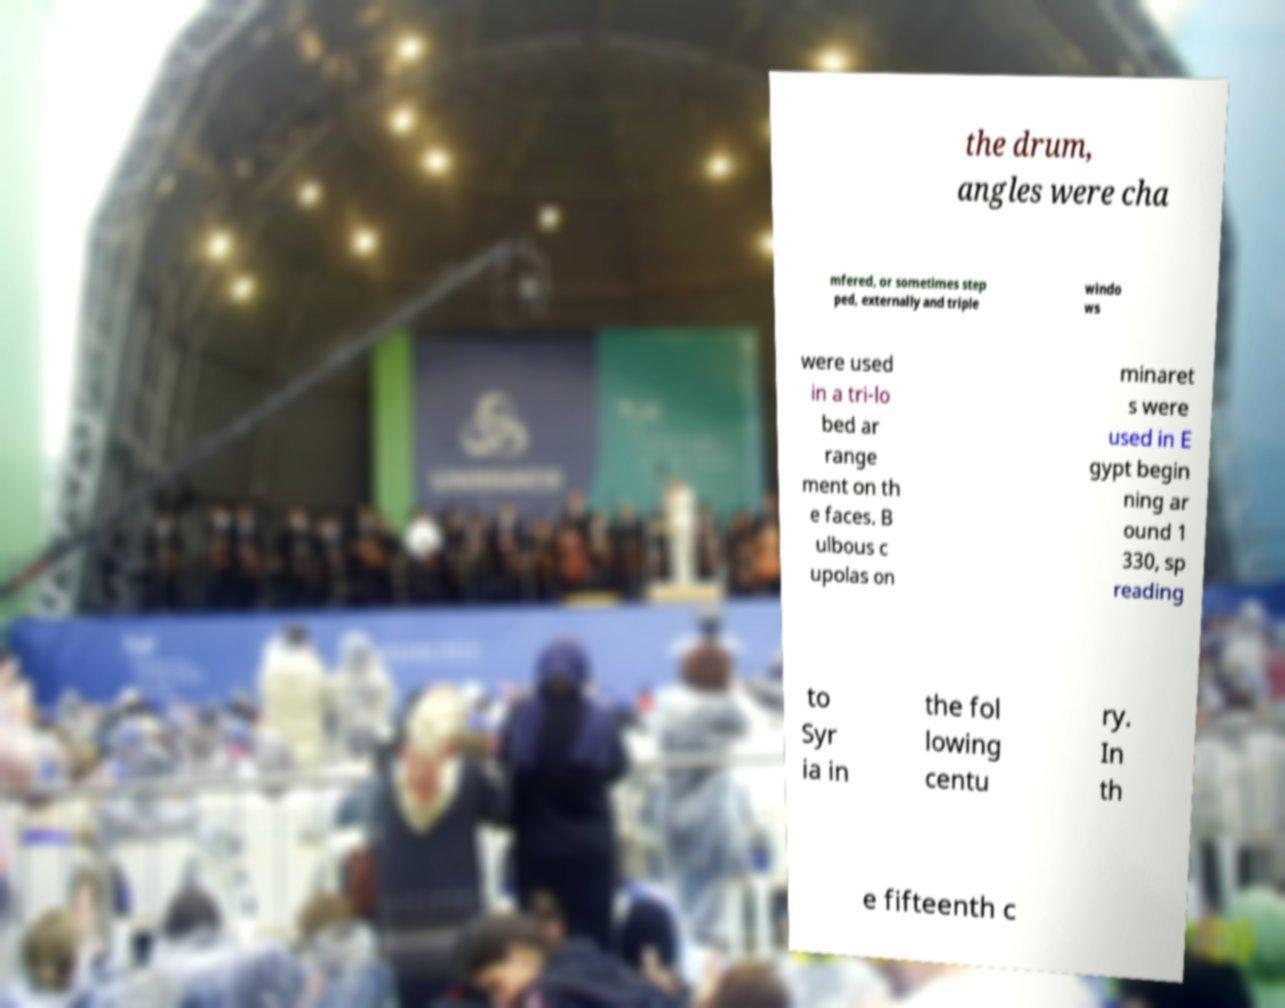Please identify and transcribe the text found in this image. the drum, angles were cha mfered, or sometimes step ped, externally and triple windo ws were used in a tri-lo bed ar range ment on th e faces. B ulbous c upolas on minaret s were used in E gypt begin ning ar ound 1 330, sp reading to Syr ia in the fol lowing centu ry. In th e fifteenth c 